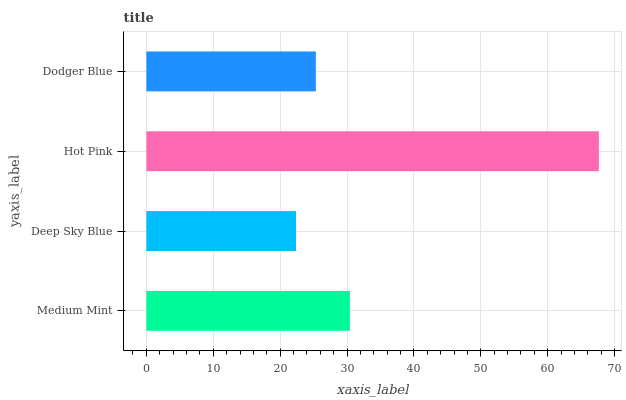Is Deep Sky Blue the minimum?
Answer yes or no. Yes. Is Hot Pink the maximum?
Answer yes or no. Yes. Is Hot Pink the minimum?
Answer yes or no. No. Is Deep Sky Blue the maximum?
Answer yes or no. No. Is Hot Pink greater than Deep Sky Blue?
Answer yes or no. Yes. Is Deep Sky Blue less than Hot Pink?
Answer yes or no. Yes. Is Deep Sky Blue greater than Hot Pink?
Answer yes or no. No. Is Hot Pink less than Deep Sky Blue?
Answer yes or no. No. Is Medium Mint the high median?
Answer yes or no. Yes. Is Dodger Blue the low median?
Answer yes or no. Yes. Is Hot Pink the high median?
Answer yes or no. No. Is Hot Pink the low median?
Answer yes or no. No. 